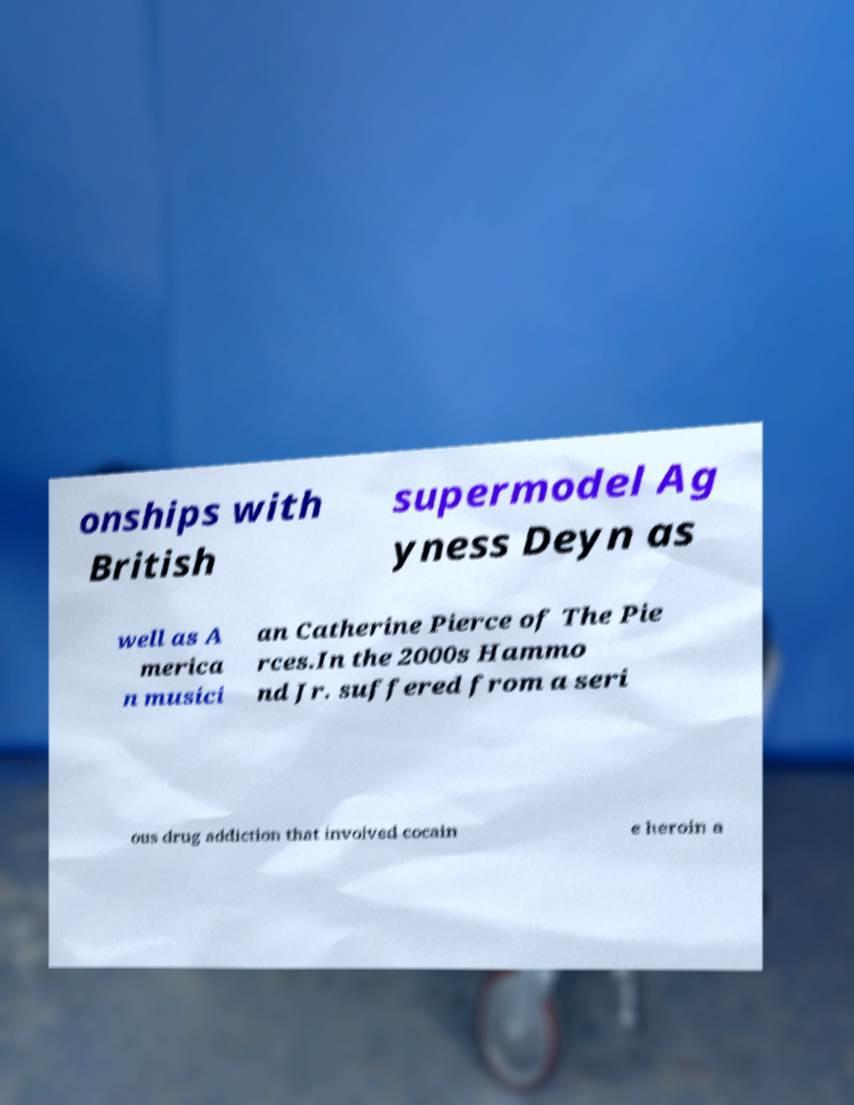Could you extract and type out the text from this image? onships with British supermodel Ag yness Deyn as well as A merica n musici an Catherine Pierce of The Pie rces.In the 2000s Hammo nd Jr. suffered from a seri ous drug addiction that involved cocain e heroin a 